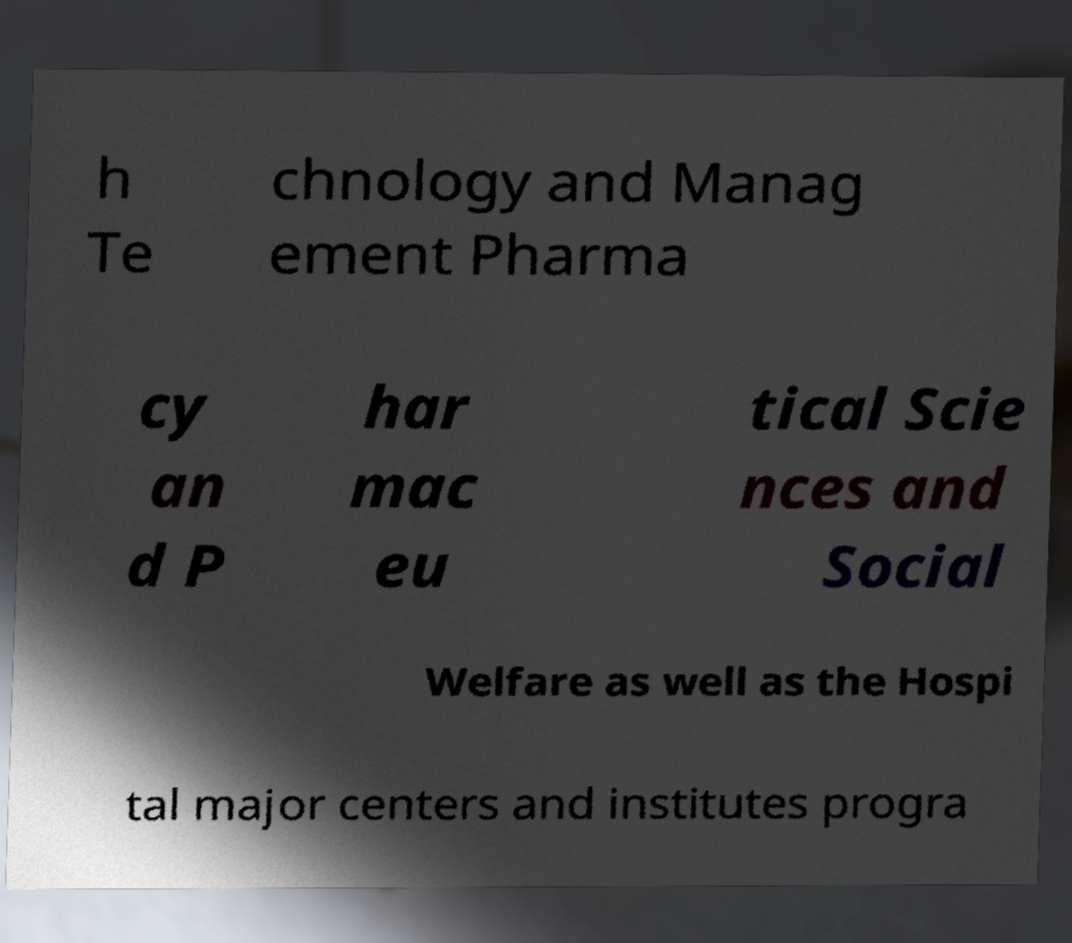Could you assist in decoding the text presented in this image and type it out clearly? h Te chnology and Manag ement Pharma cy an d P har mac eu tical Scie nces and Social Welfare as well as the Hospi tal major centers and institutes progra 